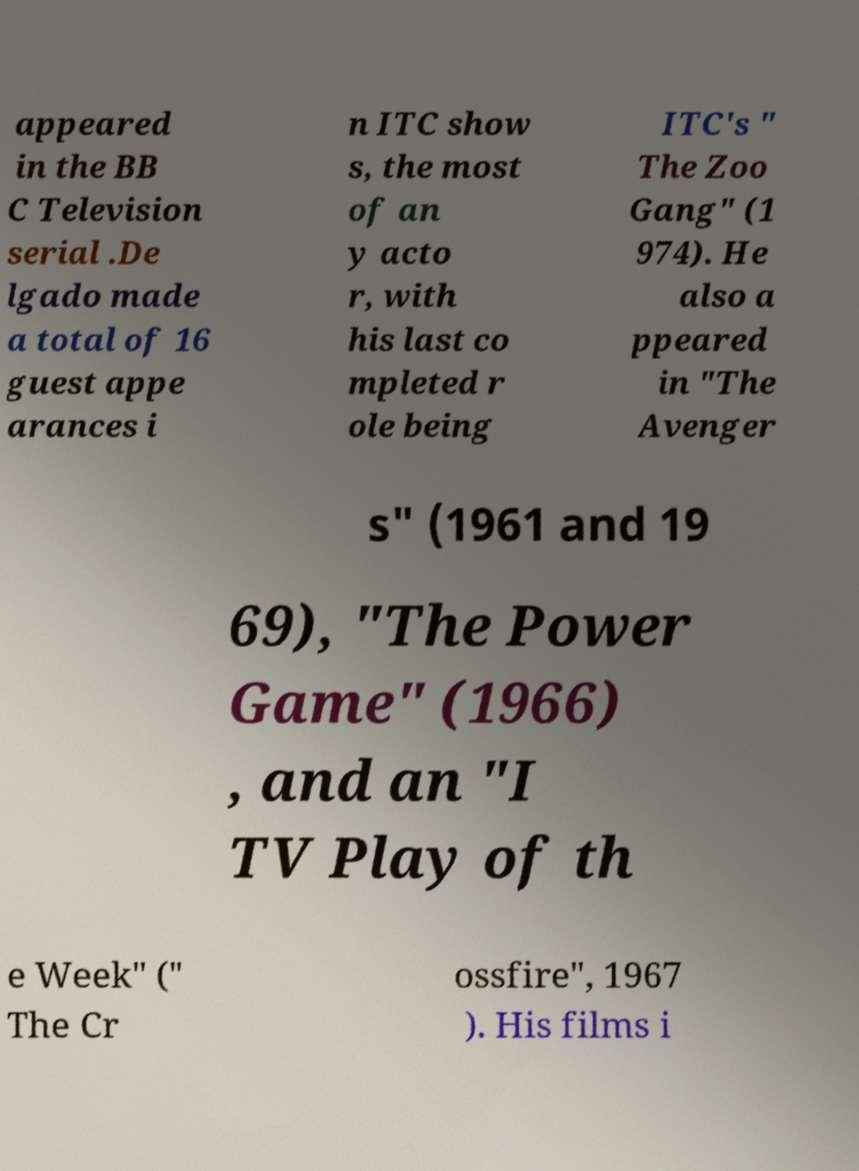There's text embedded in this image that I need extracted. Can you transcribe it verbatim? appeared in the BB C Television serial .De lgado made a total of 16 guest appe arances i n ITC show s, the most of an y acto r, with his last co mpleted r ole being ITC's " The Zoo Gang" (1 974). He also a ppeared in "The Avenger s" (1961 and 19 69), "The Power Game" (1966) , and an "I TV Play of th e Week" (" The Cr ossfire", 1967 ). His films i 